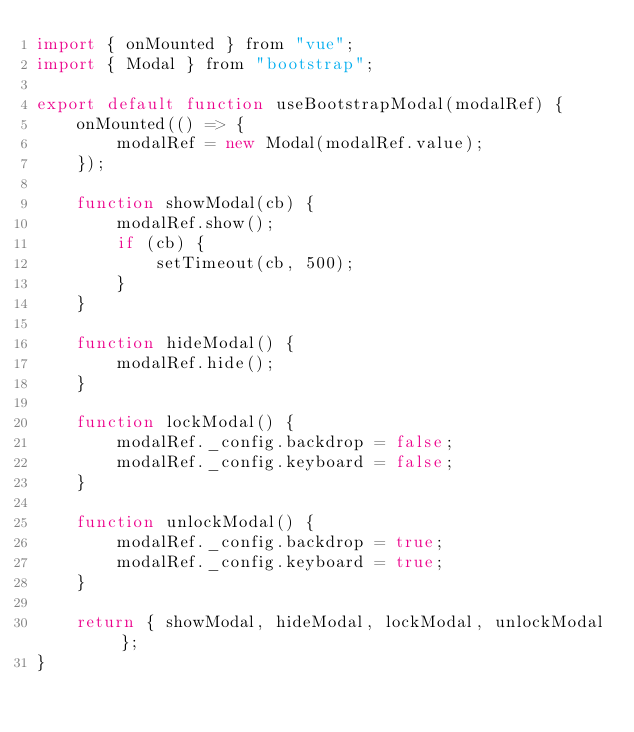<code> <loc_0><loc_0><loc_500><loc_500><_JavaScript_>import { onMounted } from "vue";
import { Modal } from "bootstrap";

export default function useBootstrapModal(modalRef) {
    onMounted(() => {
        modalRef = new Modal(modalRef.value);
    });

    function showModal(cb) {
        modalRef.show();
        if (cb) {
            setTimeout(cb, 500);
        }
    }

    function hideModal() {
        modalRef.hide();
    }

    function lockModal() {
        modalRef._config.backdrop = false;
        modalRef._config.keyboard = false;
    }

    function unlockModal() {
        modalRef._config.backdrop = true;
        modalRef._config.keyboard = true;
    }

    return { showModal, hideModal, lockModal, unlockModal };
}</code> 